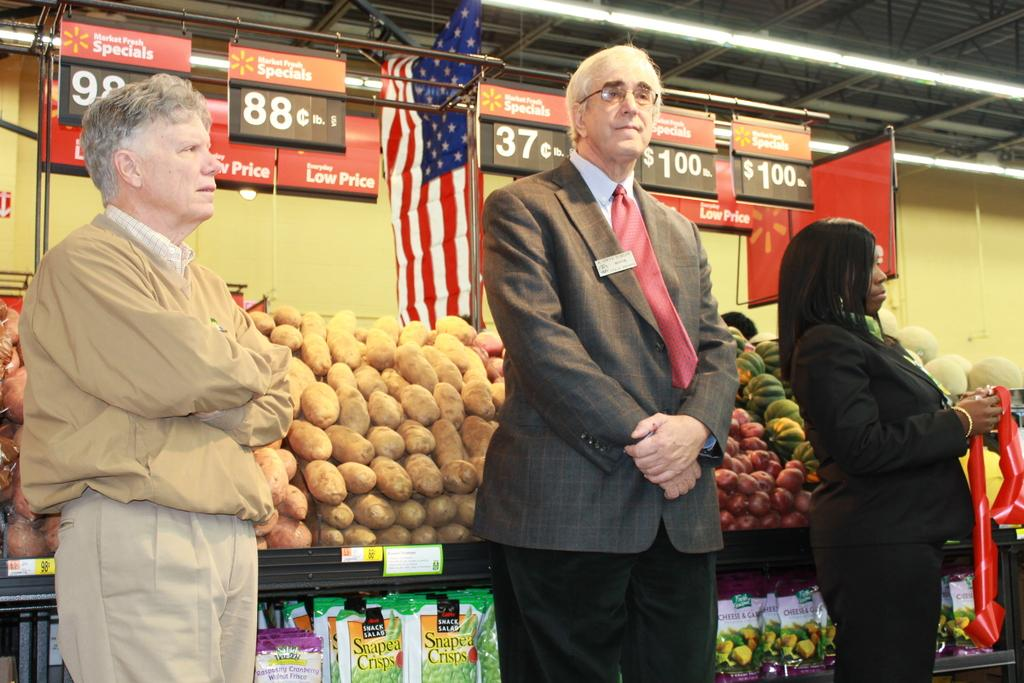Provide a one-sentence caption for the provided image. a man standing in front of a price sign that says 37 cents on it. 